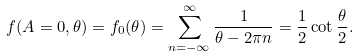<formula> <loc_0><loc_0><loc_500><loc_500>f ( A = 0 , \theta ) = f _ { 0 } ( \theta ) = \sum _ { n = - \infty } ^ { \infty } \frac { 1 } { \theta - 2 \pi n } = \frac { 1 } { 2 } \cot \frac { \theta } { 2 } .</formula> 